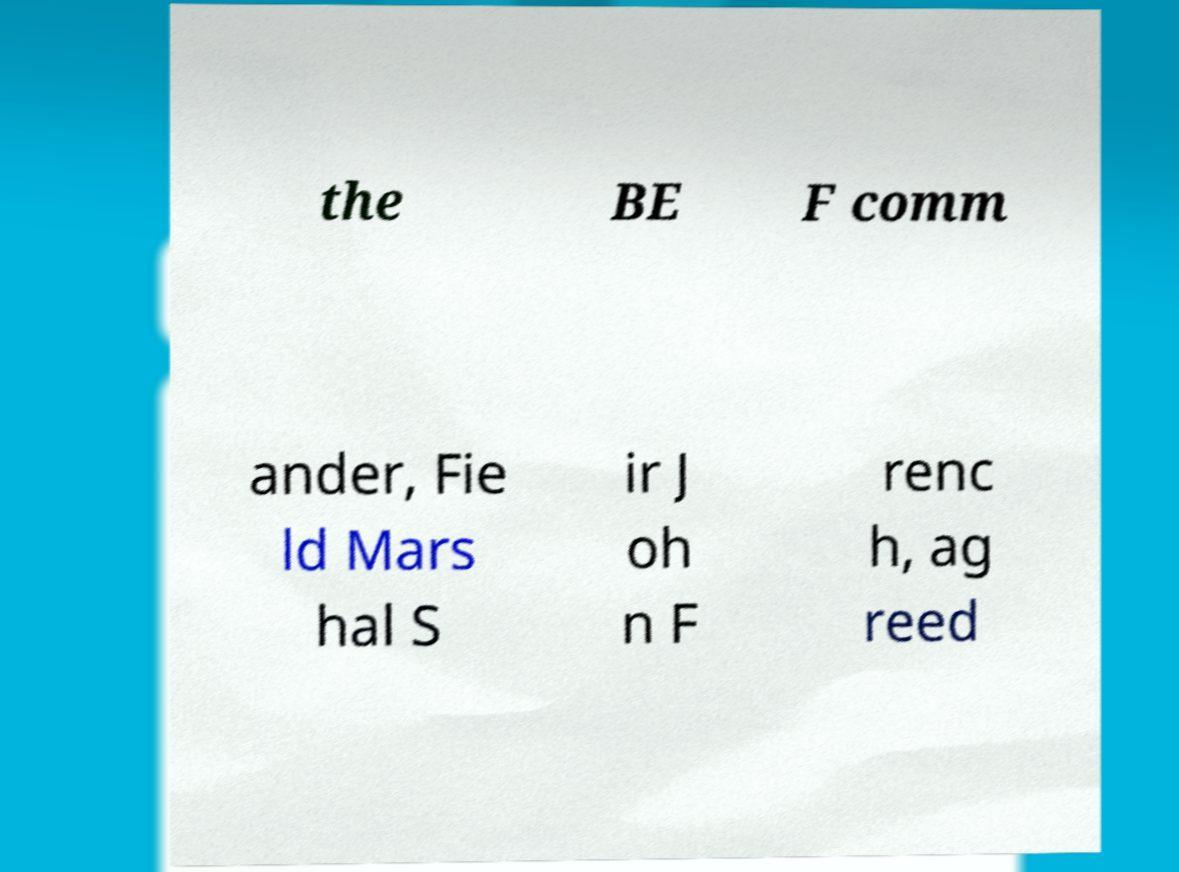Please read and relay the text visible in this image. What does it say? the BE F comm ander, Fie ld Mars hal S ir J oh n F renc h, ag reed 